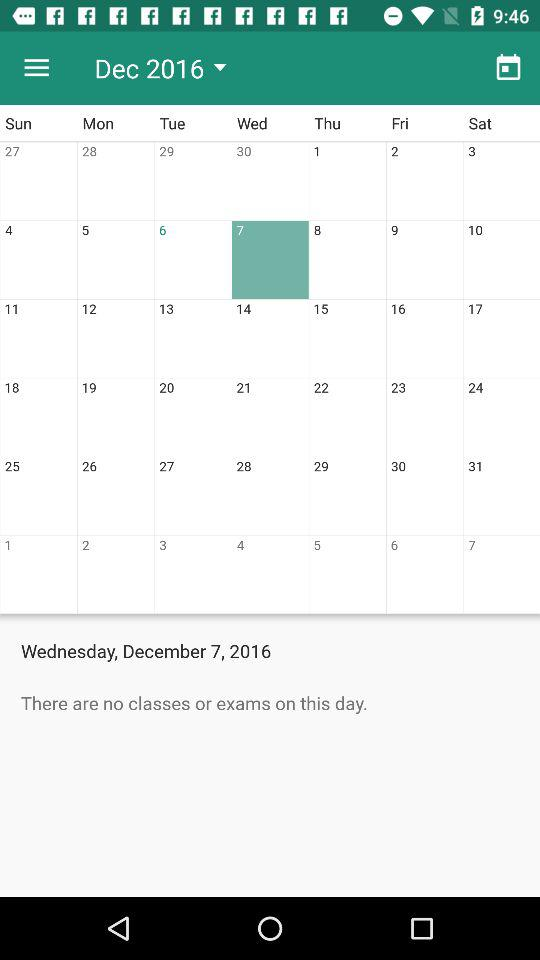Is there any exam on December 7? There is no exam on December 7. 